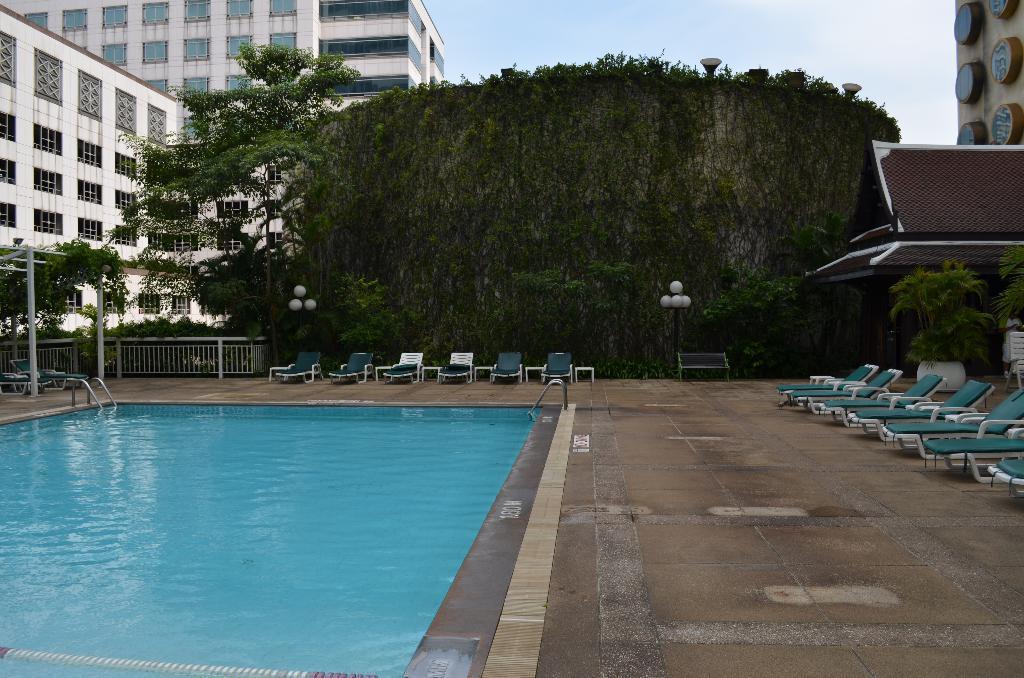Can you describe this image briefly? In the image we can see there are building and window of the building. There are trees, fence, lounge chair, bench and a bench. This is a pole and a sky. 